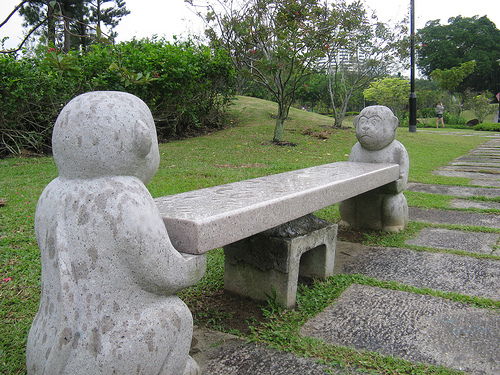<image>
Is there a statue in front of the statue? Yes. The statue is positioned in front of the statue, appearing closer to the camera viewpoint. Where is the bench in relation to the sculpture? Is it in front of the sculpture? Yes. The bench is positioned in front of the sculpture, appearing closer to the camera viewpoint. 